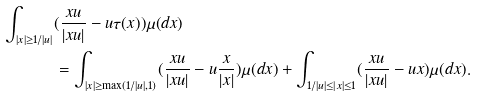<formula> <loc_0><loc_0><loc_500><loc_500>\int _ { | x | \geq 1 / | u | } & ( \frac { x u } { | x u | } - u \tau ( x ) ) \mu ( d x ) \\ & = \int _ { | x | \geq \max ( 1 / | u | , 1 ) } ( \frac { x u } { | x u | } - u \frac { x } { | x | } ) \mu ( d x ) + \int _ { 1 / | u | \leq | x | \leq 1 } ( \frac { x u } { | x u | } - u x ) \mu ( d x ) .</formula> 